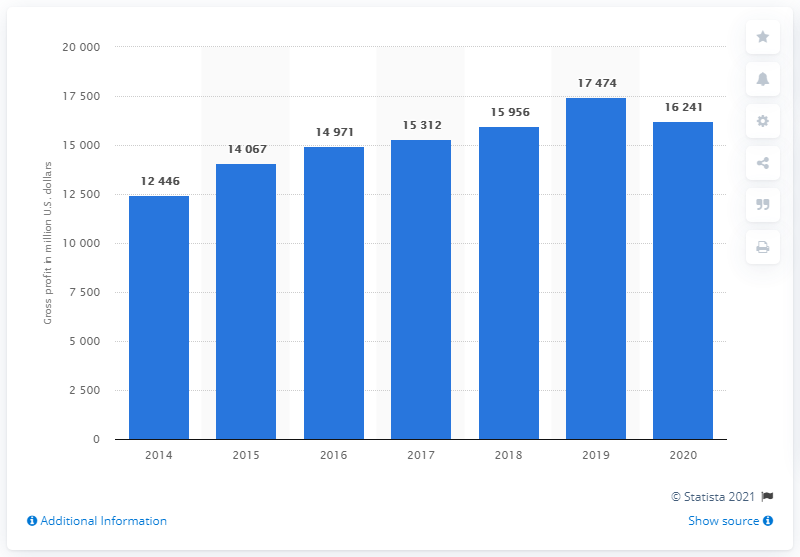What additional information might be relevant to understand this bar chart better? Additional information that would help in understanding this bar chart includes the net income figures, operational expenses, sales data across different regions, product line performance, market conditions, and the strategies Nike adopted during these years. It would also be helpful to know the impact of currency fluctuations and any significant business acquisitions or divestitures. 